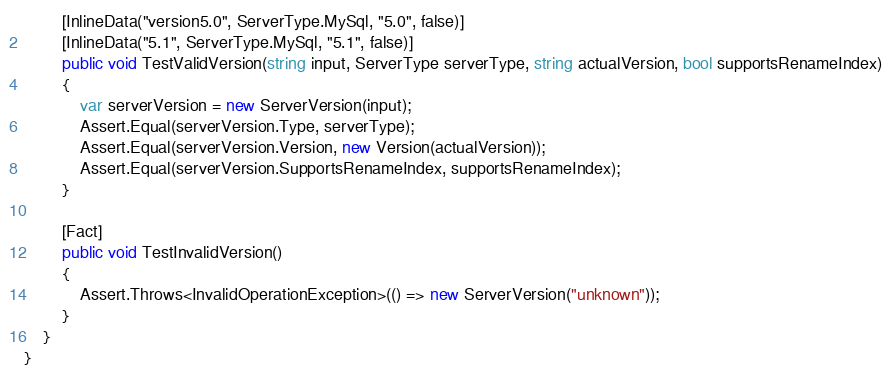<code> <loc_0><loc_0><loc_500><loc_500><_C#_>        [InlineData("version5.0", ServerType.MySql, "5.0", false)]
        [InlineData("5.1", ServerType.MySql, "5.1", false)]
        public void TestValidVersion(string input, ServerType serverType, string actualVersion, bool supportsRenameIndex)
        {
            var serverVersion = new ServerVersion(input);
            Assert.Equal(serverVersion.Type, serverType);
            Assert.Equal(serverVersion.Version, new Version(actualVersion));
            Assert.Equal(serverVersion.SupportsRenameIndex, supportsRenameIndex);
        }

        [Fact]
        public void TestInvalidVersion()
        {
            Assert.Throws<InvalidOperationException>(() => new ServerVersion("unknown"));
        }
    }
}
</code> 